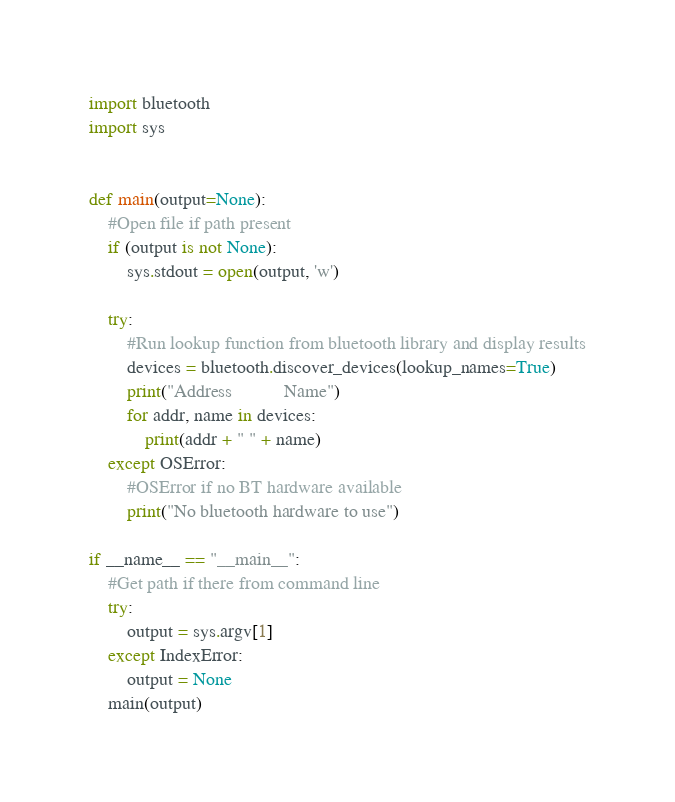Convert code to text. <code><loc_0><loc_0><loc_500><loc_500><_Python_>import bluetooth
import sys


def main(output=None):
	#Open file if path present
	if (output is not None):
		sys.stdout = open(output, 'w')
	
	try:
		#Run lookup function from bluetooth library and display results
		devices = bluetooth.discover_devices(lookup_names=True)
		print("Address           Name") 
		for addr, name in devices:
			print(addr + " " + name)
	except OSError:
		#OSError if no BT hardware available
		print("No bluetooth hardware to use")

if __name__ == "__main__":
	#Get path if there from command line
	try:
		output = sys.argv[1]
	except IndexError:
		output = None
	main(output)

</code> 